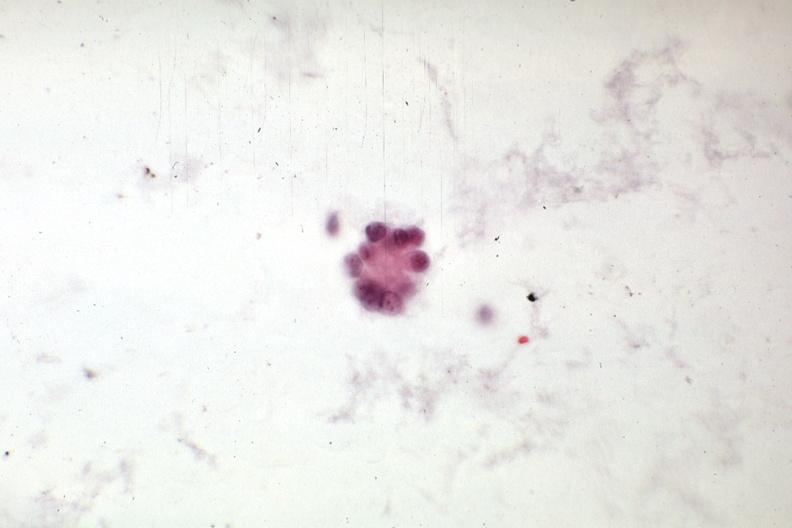does this image show adenocarcinoma from mixed mesodermal uterine tumor?
Answer the question using a single word or phrase. Yes 